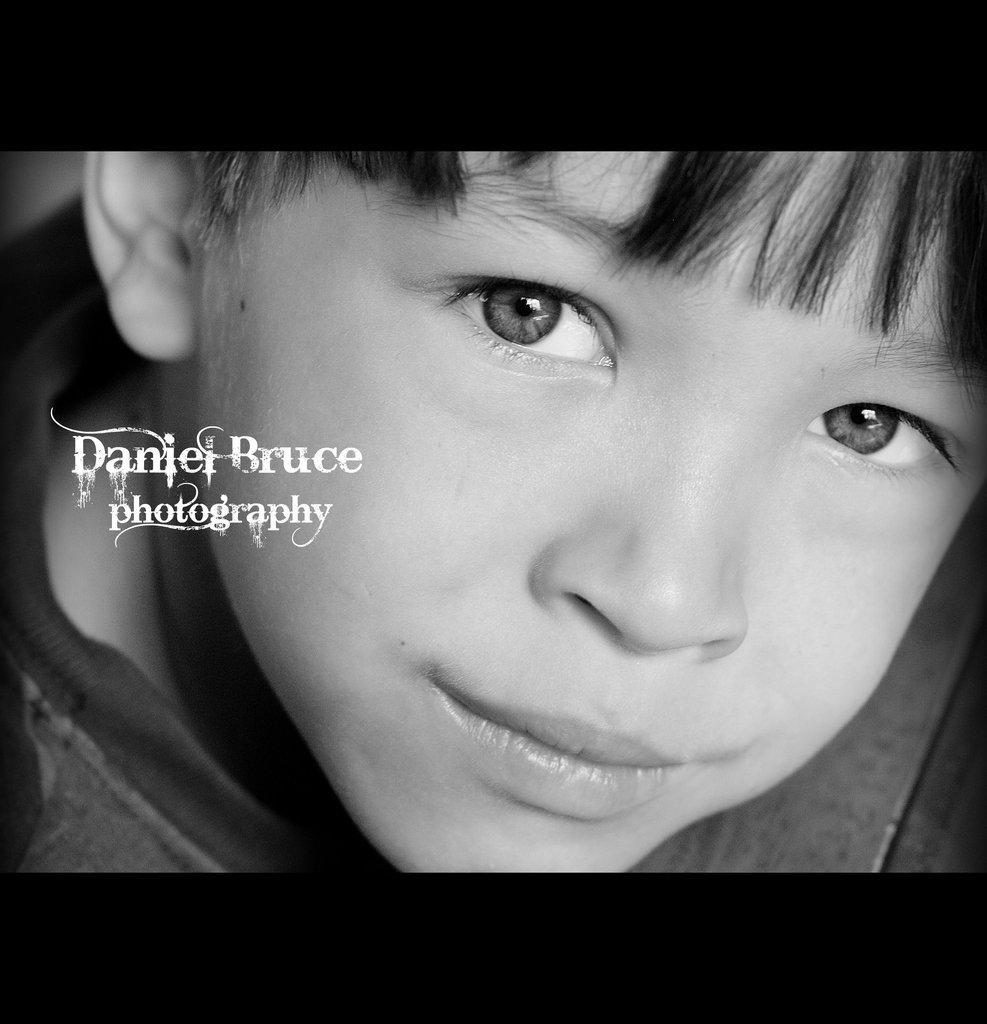What is the main subject of the picture? The main subject of the picture is a kid's face. Can you describe anything else present in the image? Yes, there is some text on the left side of the picture. How many cattle can be seen in the picture? There are no cattle present in the picture. What type of owl can be seen perched on the kid's shoulder in the picture? There is no owl present in the picture. 